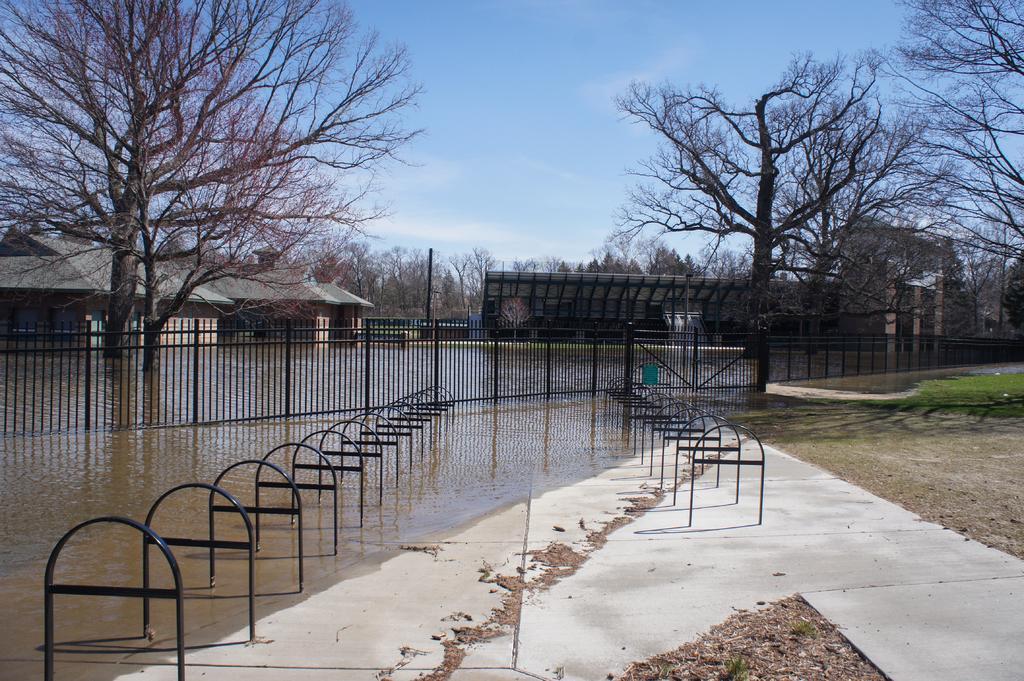Could you give a brief overview of what you see in this image? These are the trees with the branches. I think these are the kind of poles. This looks like the iron grills, which are black in color. I can see the buildings. These are the water. Here is the grass. 